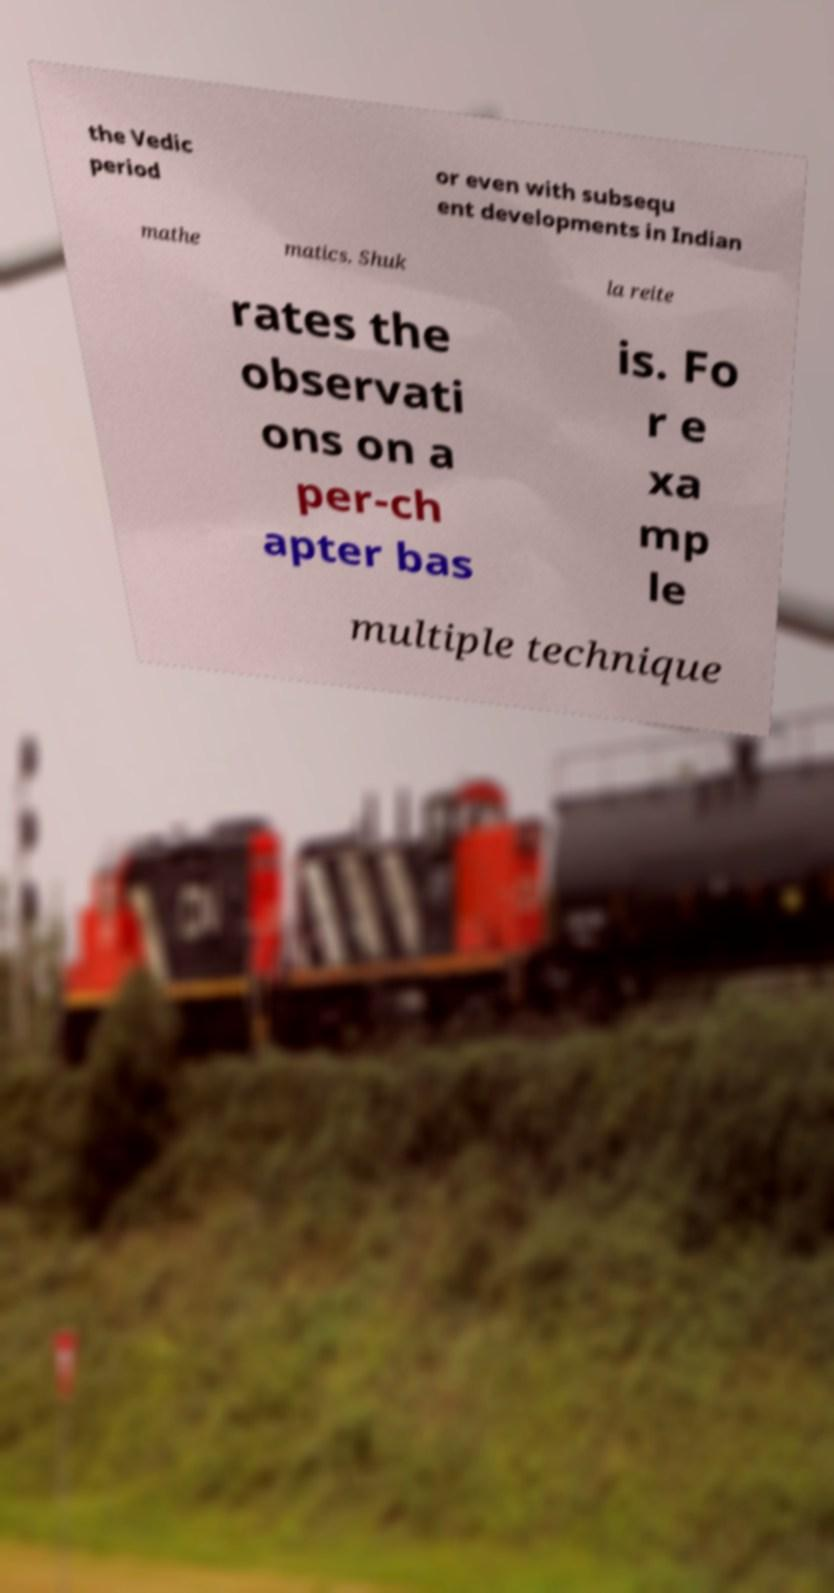What messages or text are displayed in this image? I need them in a readable, typed format. the Vedic period or even with subsequ ent developments in Indian mathe matics. Shuk la reite rates the observati ons on a per-ch apter bas is. Fo r e xa mp le multiple technique 